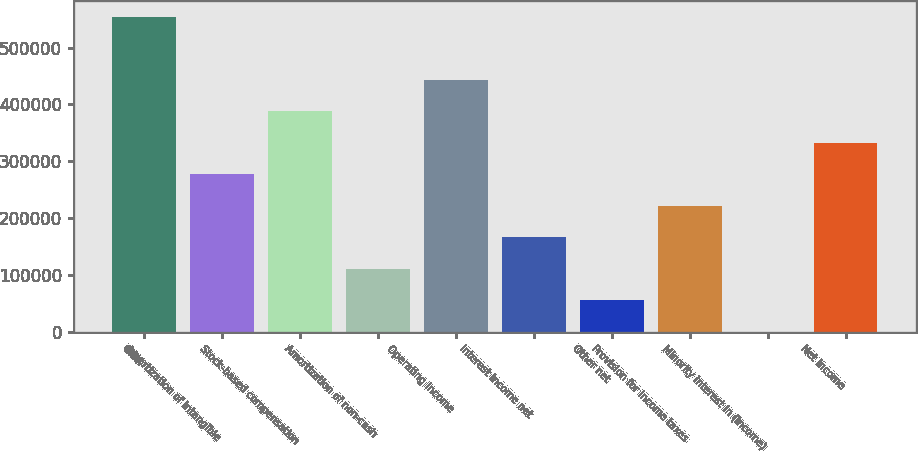<chart> <loc_0><loc_0><loc_500><loc_500><bar_chart><fcel>OIBA<fcel>Amortization of intangible<fcel>Stock-based compensation<fcel>Amortization of non-cash<fcel>Operating Income<fcel>Interest income net<fcel>Other net<fcel>Provision for income taxes<fcel>Minority interest in (income)<fcel>Net Income<nl><fcel>553692<fcel>276996<fcel>387675<fcel>110979<fcel>443014<fcel>166318<fcel>55640.1<fcel>221657<fcel>301<fcel>332336<nl></chart> 